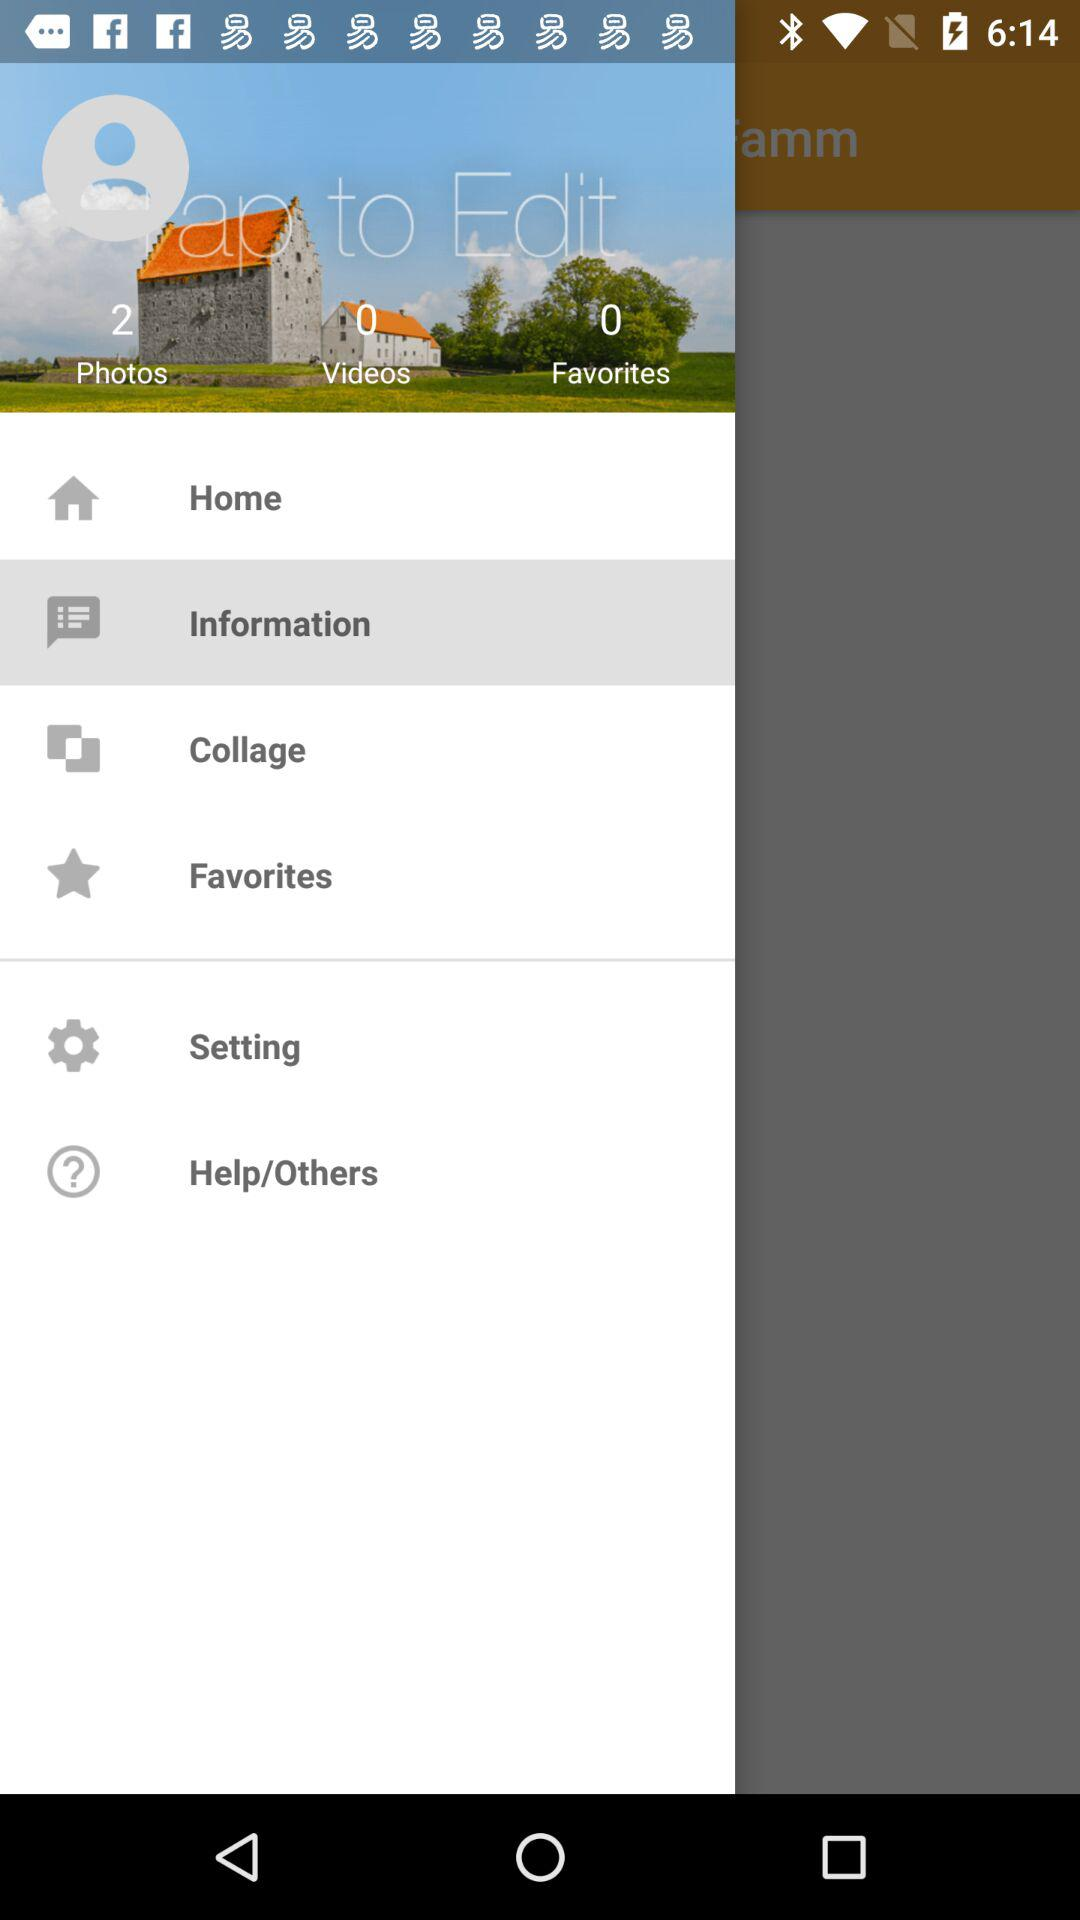How many videos are there? There are 0 videos. 